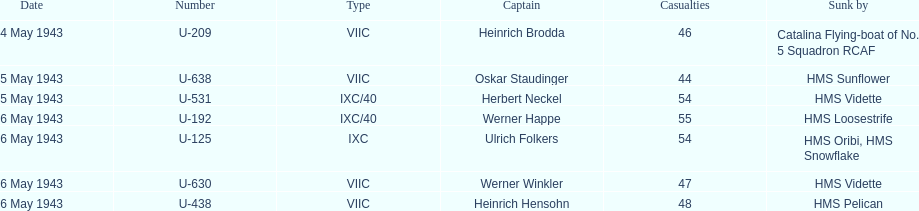Who were the captains in the ons 5 convoy? Heinrich Brodda, Oskar Staudinger, Herbert Neckel, Werner Happe, Ulrich Folkers, Werner Winkler, Heinrich Hensohn. Which ones lost their u-boat on may 5? Oskar Staudinger, Herbert Neckel. Of those, which one is not oskar staudinger? Herbert Neckel. 